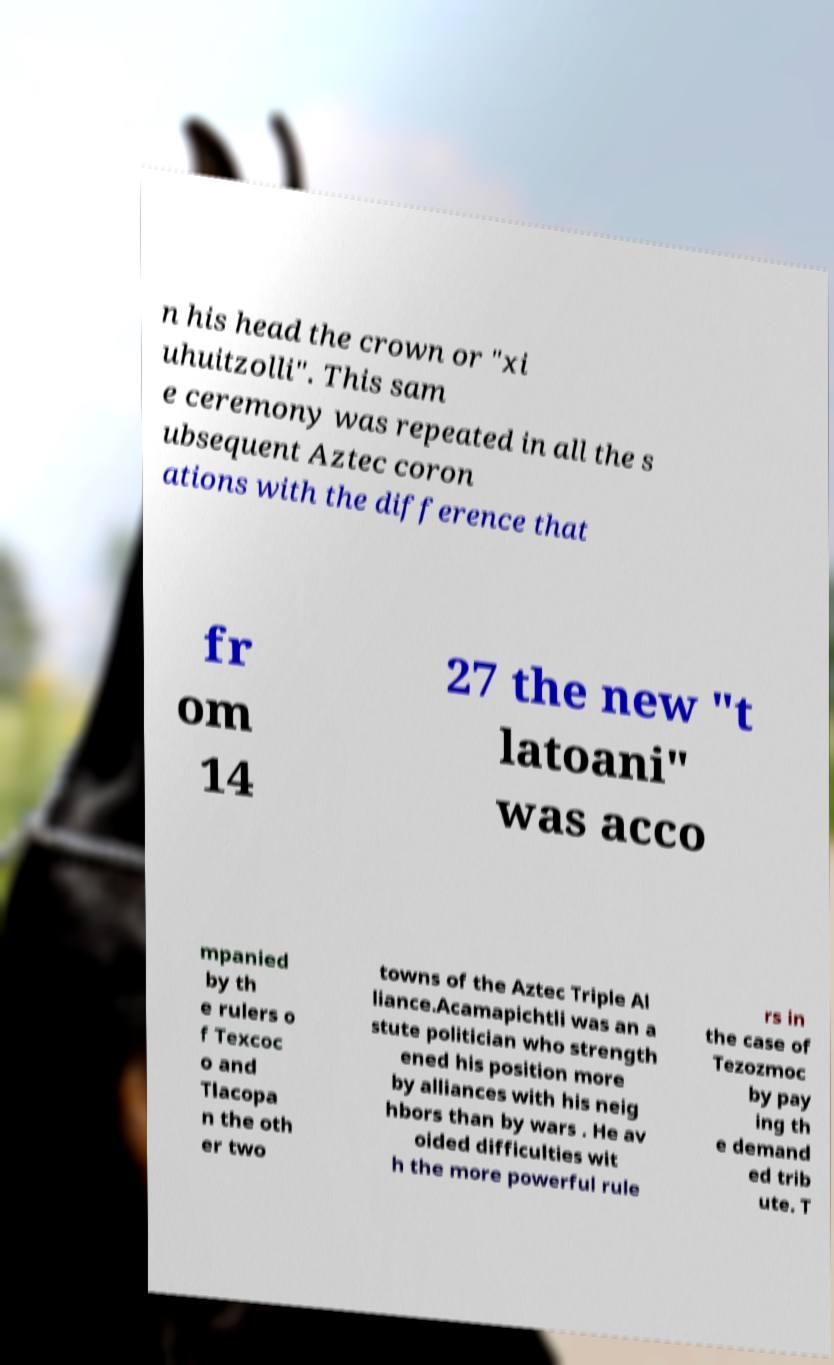I need the written content from this picture converted into text. Can you do that? n his head the crown or "xi uhuitzolli". This sam e ceremony was repeated in all the s ubsequent Aztec coron ations with the difference that fr om 14 27 the new "t latoani" was acco mpanied by th e rulers o f Texcoc o and Tlacopa n the oth er two towns of the Aztec Triple Al liance.Acamapichtli was an a stute politician who strength ened his position more by alliances with his neig hbors than by wars . He av oided difficulties wit h the more powerful rule rs in the case of Tezozmoc by pay ing th e demand ed trib ute. T 